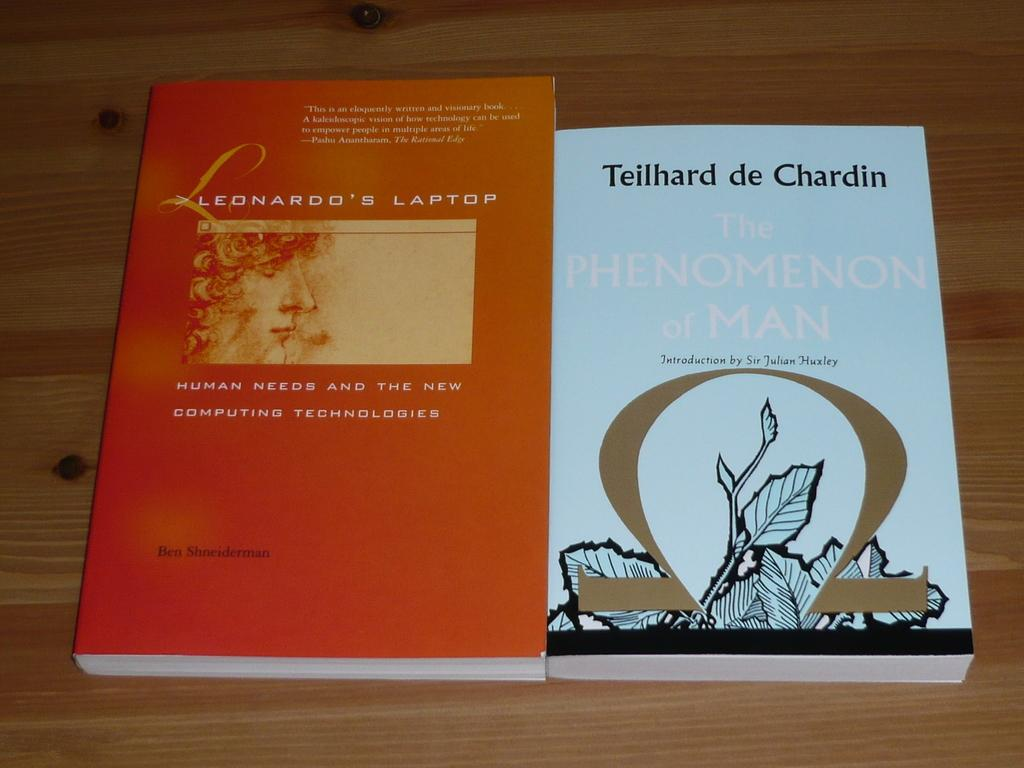<image>
Relay a brief, clear account of the picture shown. Two books on a tabletop with one named Leonardo's Laptop. 